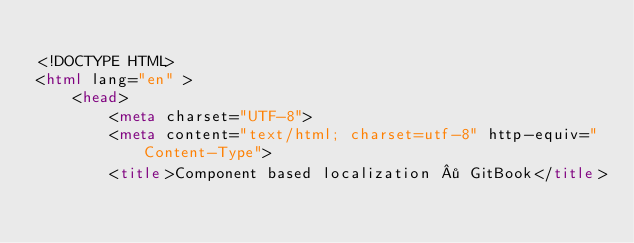Convert code to text. <code><loc_0><loc_0><loc_500><loc_500><_HTML_>
<!DOCTYPE HTML>
<html lang="en" >
    <head>
        <meta charset="UTF-8">
        <meta content="text/html; charset=utf-8" http-equiv="Content-Type">
        <title>Component based localization · GitBook</title></code> 